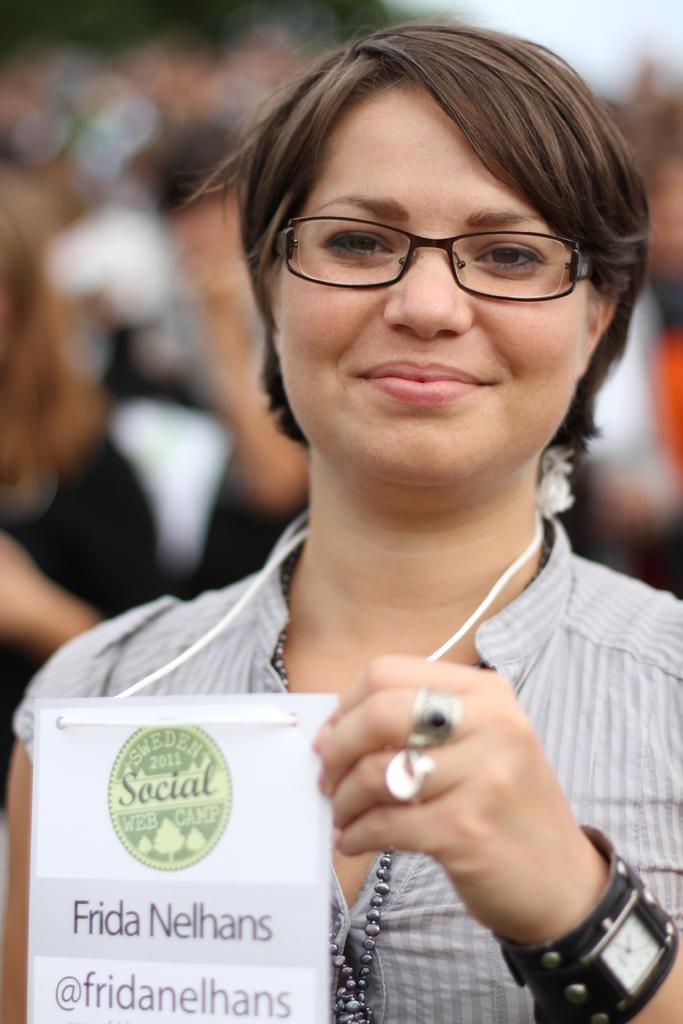Describe this image in one or two sentences. In this image I can see the person with the ash color dress and specs. The person is holding the card. In the background there are group of people but they are blurry. 